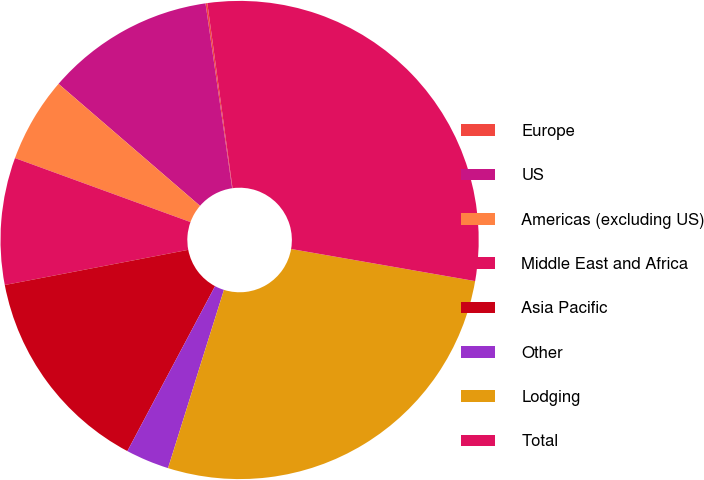<chart> <loc_0><loc_0><loc_500><loc_500><pie_chart><fcel>Europe<fcel>US<fcel>Americas (excluding US)<fcel>Middle East and Africa<fcel>Asia Pacific<fcel>Other<fcel>Lodging<fcel>Total<nl><fcel>0.12%<fcel>11.4%<fcel>5.76%<fcel>8.58%<fcel>14.21%<fcel>2.94%<fcel>27.09%<fcel>29.91%<nl></chart> 